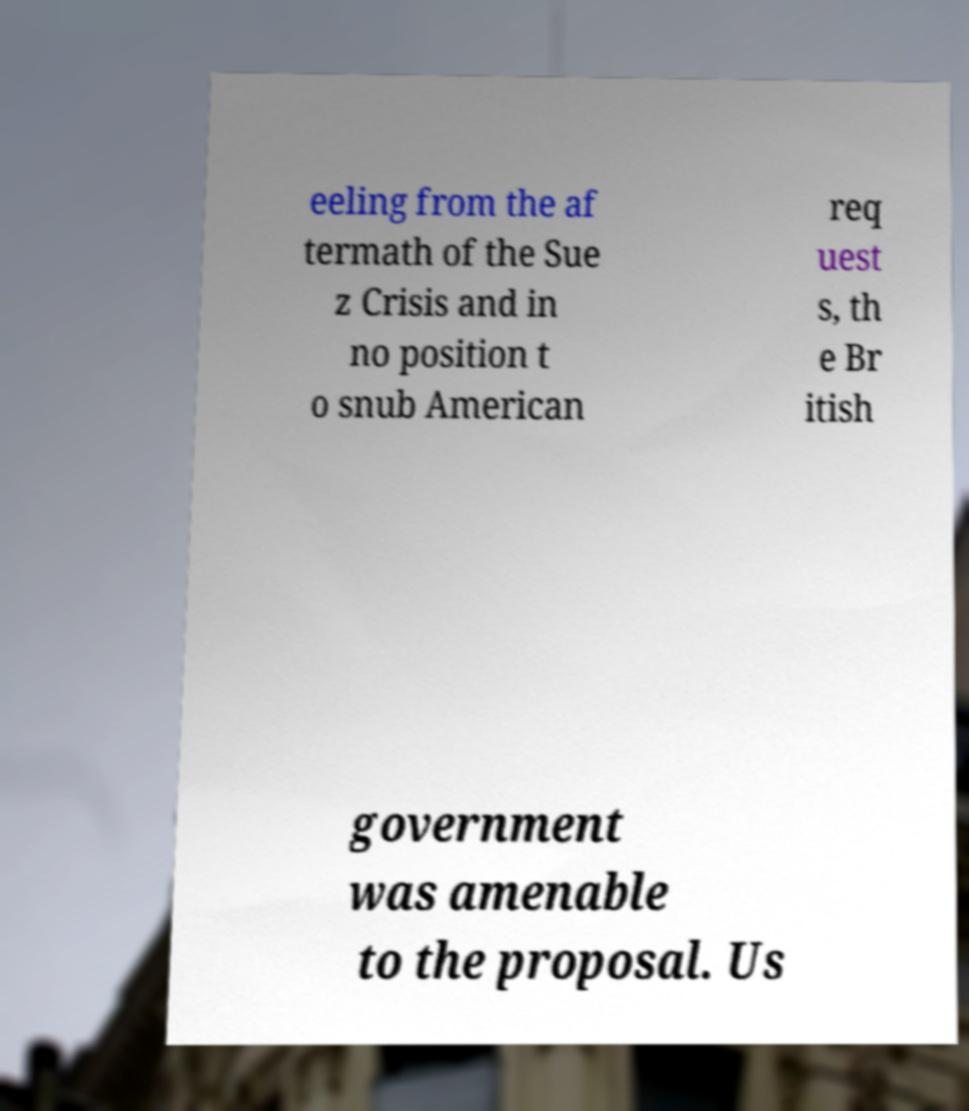For documentation purposes, I need the text within this image transcribed. Could you provide that? eeling from the af termath of the Sue z Crisis and in no position t o snub American req uest s, th e Br itish government was amenable to the proposal. Us 